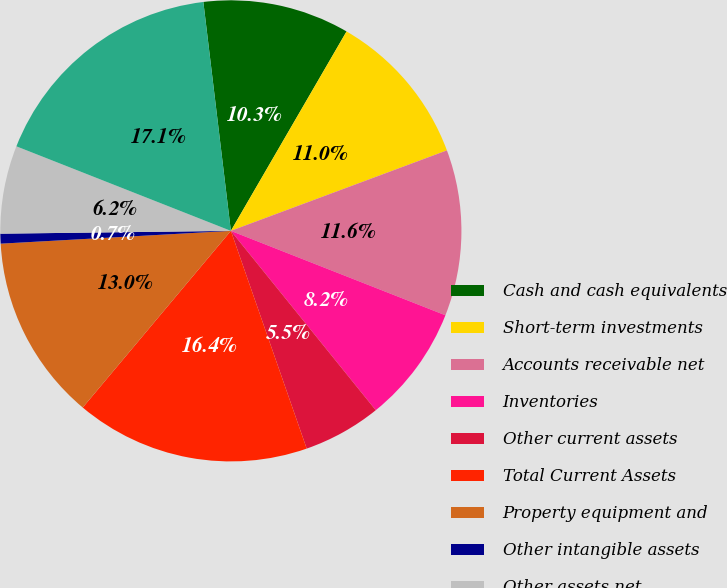<chart> <loc_0><loc_0><loc_500><loc_500><pie_chart><fcel>Cash and cash equivalents<fcel>Short-term investments<fcel>Accounts receivable net<fcel>Inventories<fcel>Other current assets<fcel>Total Current Assets<fcel>Property equipment and<fcel>Other intangible assets<fcel>Other assets net<fcel>Total Assets<nl><fcel>10.27%<fcel>10.96%<fcel>11.64%<fcel>8.22%<fcel>5.48%<fcel>16.44%<fcel>13.01%<fcel>0.69%<fcel>6.17%<fcel>17.12%<nl></chart> 